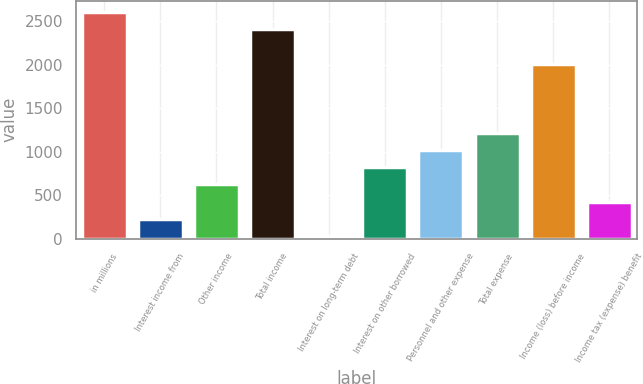Convert chart to OTSL. <chart><loc_0><loc_0><loc_500><loc_500><bar_chart><fcel>in millions<fcel>Interest income from<fcel>Other income<fcel>Total income<fcel>Interest on long-term debt<fcel>Interest on other borrowed<fcel>Personnel and other expense<fcel>Total expense<fcel>Income (loss) before income<fcel>Income tax (expense) benefit<nl><fcel>2606.9<fcel>227.3<fcel>623.9<fcel>2408.6<fcel>29<fcel>822.2<fcel>1020.5<fcel>1218.8<fcel>2012<fcel>425.6<nl></chart> 